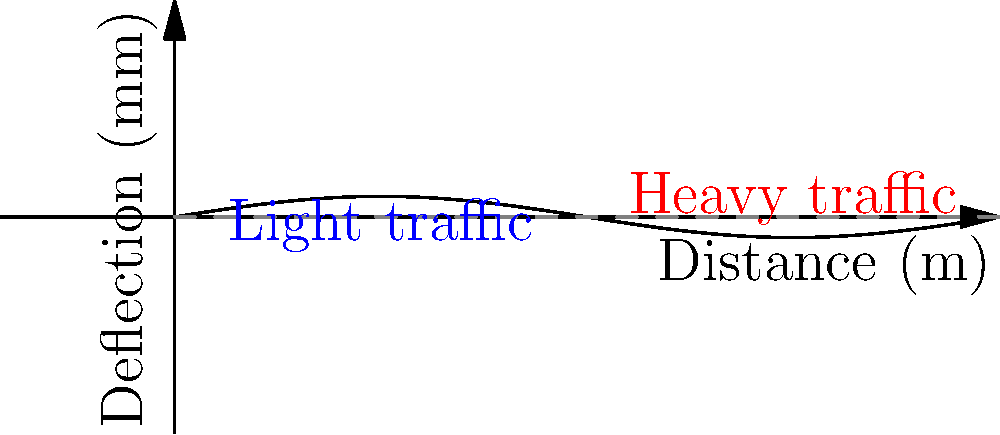A suspension bridge experiences different levels of deflection based on traffic load. The graph shows the deflection pattern under light and heavy traffic conditions. If the maximum allowable deflection is 0.6 mm, what is the approximate percentage increase in deflection from light to heavy traffic, and does it exceed the safety threshold? To solve this problem, we need to follow these steps:

1. Identify the maximum deflection for light traffic:
   From the graph, the peak of the blue curve is approximately 0.25 mm.

2. Identify the maximum deflection for heavy traffic:
   From the graph, the peak of the red curve is approximately 0.5 mm.

3. Calculate the percentage increase:
   Percentage increase = (New value - Original value) / Original value * 100
   = (0.5 - 0.25) / 0.25 * 100
   = 0.25 / 0.25 * 100
   = 1 * 100 = 100%

4. Compare with the safety threshold:
   The maximum allowable deflection is 0.6 mm.
   The maximum deflection under heavy traffic (0.5 mm) is less than 0.6 mm.

Therefore, the deflection increases by approximately 100% from light to heavy traffic, but it does not exceed the safety threshold of 0.6 mm.
Answer: 100% increase; does not exceed threshold 